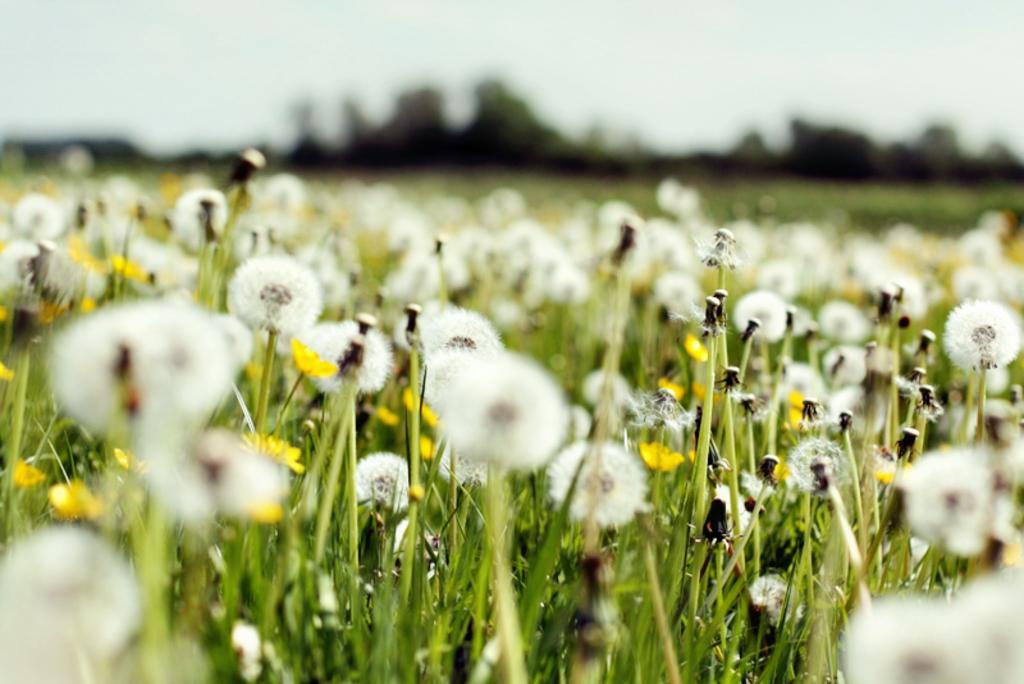Could you give a brief overview of what you see in this image? In this image we can see flowers. At the bottom there is grass. In the background there is sky. 